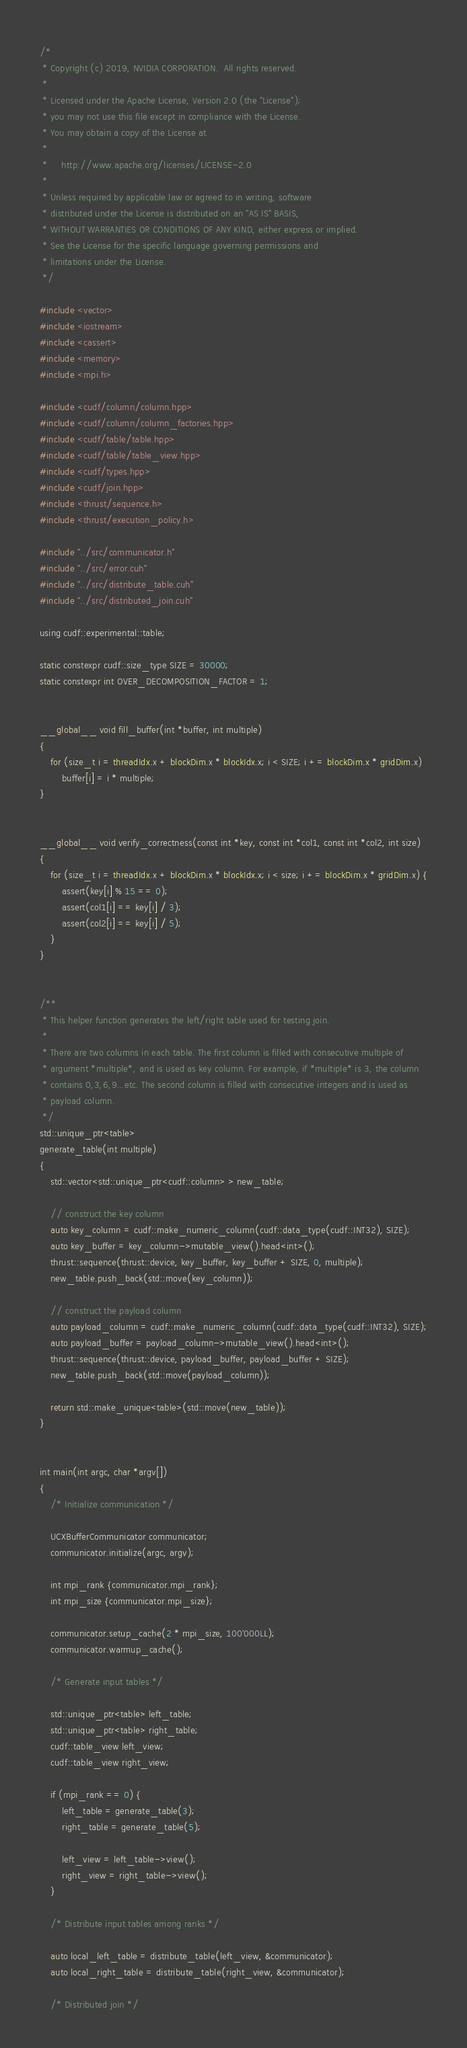Convert code to text. <code><loc_0><loc_0><loc_500><loc_500><_Cuda_>/*
 * Copyright (c) 2019, NVIDIA CORPORATION.  All rights reserved.
 *
 * Licensed under the Apache License, Version 2.0 (the "License");
 * you may not use this file except in compliance with the License.
 * You may obtain a copy of the License at
 *
 *     http://www.apache.org/licenses/LICENSE-2.0
 *
 * Unless required by applicable law or agreed to in writing, software
 * distributed under the License is distributed on an "AS IS" BASIS,
 * WITHOUT WARRANTIES OR CONDITIONS OF ANY KIND, either express or implied.
 * See the License for the specific language governing permissions and
 * limitations under the License.
 */

#include <vector>
#include <iostream>
#include <cassert>
#include <memory>
#include <mpi.h>

#include <cudf/column/column.hpp>
#include <cudf/column/column_factories.hpp>
#include <cudf/table/table.hpp>
#include <cudf/table/table_view.hpp>
#include <cudf/types.hpp>
#include <cudf/join.hpp>
#include <thrust/sequence.h>
#include <thrust/execution_policy.h>

#include "../src/communicator.h"
#include "../src/error.cuh"
#include "../src/distribute_table.cuh"
#include "../src/distributed_join.cuh"

using cudf::experimental::table;

static constexpr cudf::size_type SIZE = 30000;
static constexpr int OVER_DECOMPOSITION_FACTOR = 1;


__global__ void fill_buffer(int *buffer, int multiple)
{
    for (size_t i = threadIdx.x + blockDim.x * blockIdx.x; i < SIZE; i += blockDim.x * gridDim.x)
        buffer[i] = i * multiple;
}


__global__ void verify_correctness(const int *key, const int *col1, const int *col2, int size)
{
    for (size_t i = threadIdx.x + blockDim.x * blockIdx.x; i < size; i += blockDim.x * gridDim.x) {
        assert(key[i] % 15 == 0);
        assert(col1[i] == key[i] / 3);
        assert(col2[i] == key[i] / 5);
    }
}


/**
 * This helper function generates the left/right table used for testing join.
 *
 * There are two columns in each table. The first column is filled with consecutive multiple of
 * argument *multiple*, and is used as key column. For example, if *multiple* is 3, the column
 * contains 0,3,6,9...etc. The second column is filled with consecutive integers and is used as
 * payload column.
 */
std::unique_ptr<table>
generate_table(int multiple)
{
    std::vector<std::unique_ptr<cudf::column> > new_table;

    // construct the key column
    auto key_column = cudf::make_numeric_column(cudf::data_type(cudf::INT32), SIZE);
    auto key_buffer = key_column->mutable_view().head<int>();
    thrust::sequence(thrust::device, key_buffer, key_buffer + SIZE, 0, multiple);
    new_table.push_back(std::move(key_column));

    // construct the payload column
    auto payload_column = cudf::make_numeric_column(cudf::data_type(cudf::INT32), SIZE);
    auto payload_buffer = payload_column->mutable_view().head<int>();
    thrust::sequence(thrust::device, payload_buffer, payload_buffer + SIZE);
    new_table.push_back(std::move(payload_column));

    return std::make_unique<table>(std::move(new_table));
}


int main(int argc, char *argv[])
{
    /* Initialize communication */

    UCXBufferCommunicator communicator;
    communicator.initialize(argc, argv);

    int mpi_rank {communicator.mpi_rank};
    int mpi_size {communicator.mpi_size};

    communicator.setup_cache(2 * mpi_size, 100'000LL);
    communicator.warmup_cache();

    /* Generate input tables */

    std::unique_ptr<table> left_table;
    std::unique_ptr<table> right_table;
    cudf::table_view left_view;
    cudf::table_view right_view;

    if (mpi_rank == 0) {
        left_table = generate_table(3);
        right_table = generate_table(5);

        left_view = left_table->view();
        right_view = right_table->view();
    }

    /* Distribute input tables among ranks */

    auto local_left_table = distribute_table(left_view, &communicator);
    auto local_right_table = distribute_table(right_view, &communicator);

    /* Distributed join */
</code> 